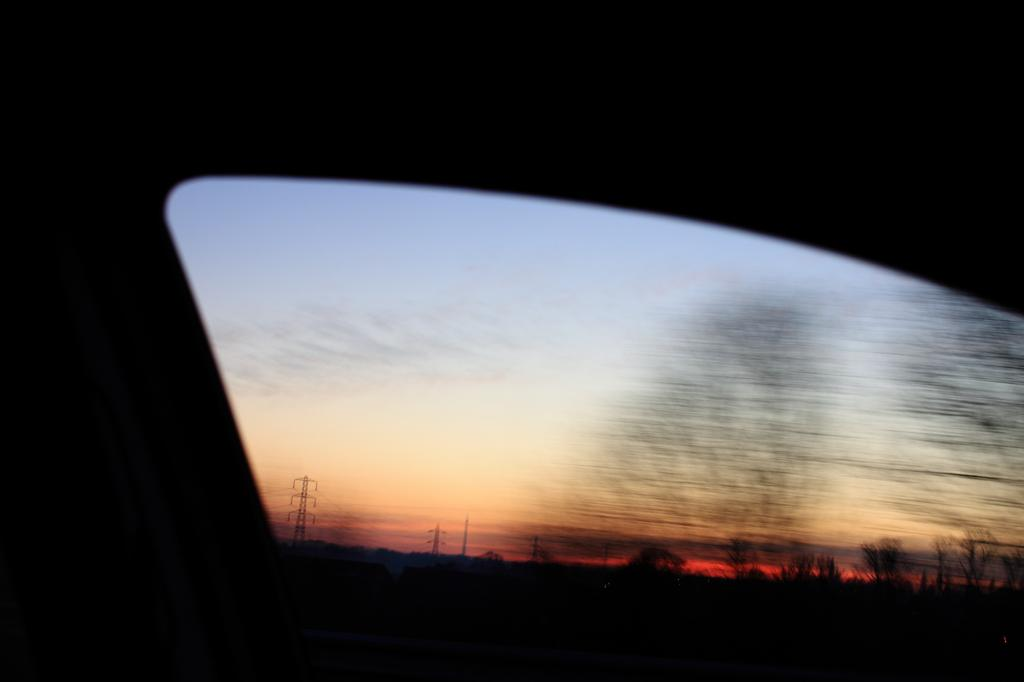What type of structure is present in the image? There is a glass window in the image. What can be seen through the glass window? Towers, trees, and the sky are visible through the glass window. What type of wood can be seen being used to construct the machine in the image? There is no machine or wood present in the image; it features a glass window with views of towers, trees, and the sky. 